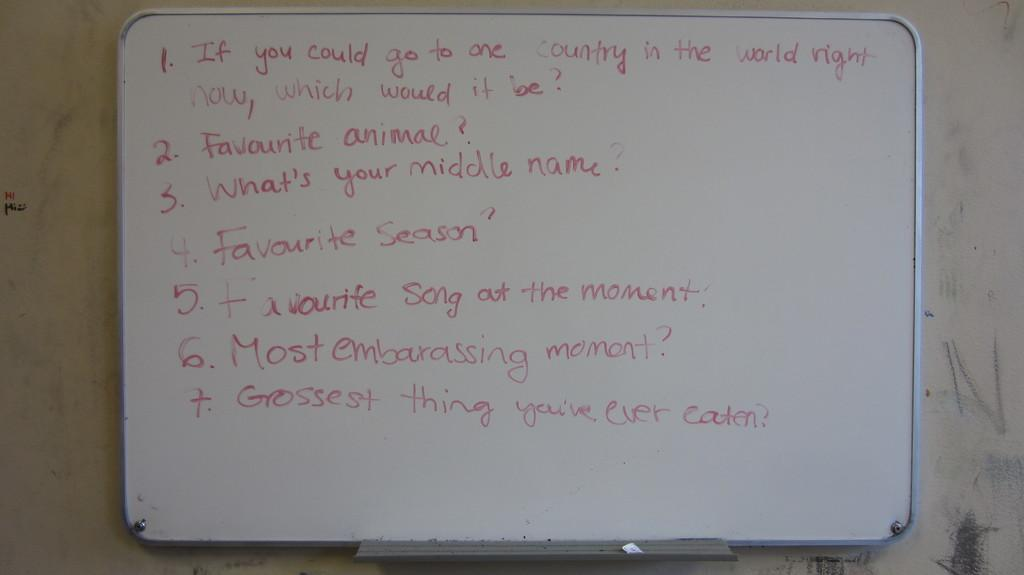Provide a one-sentence caption for the provided image. A whiteboard asks a number of questions, including "Favourite animal?". 